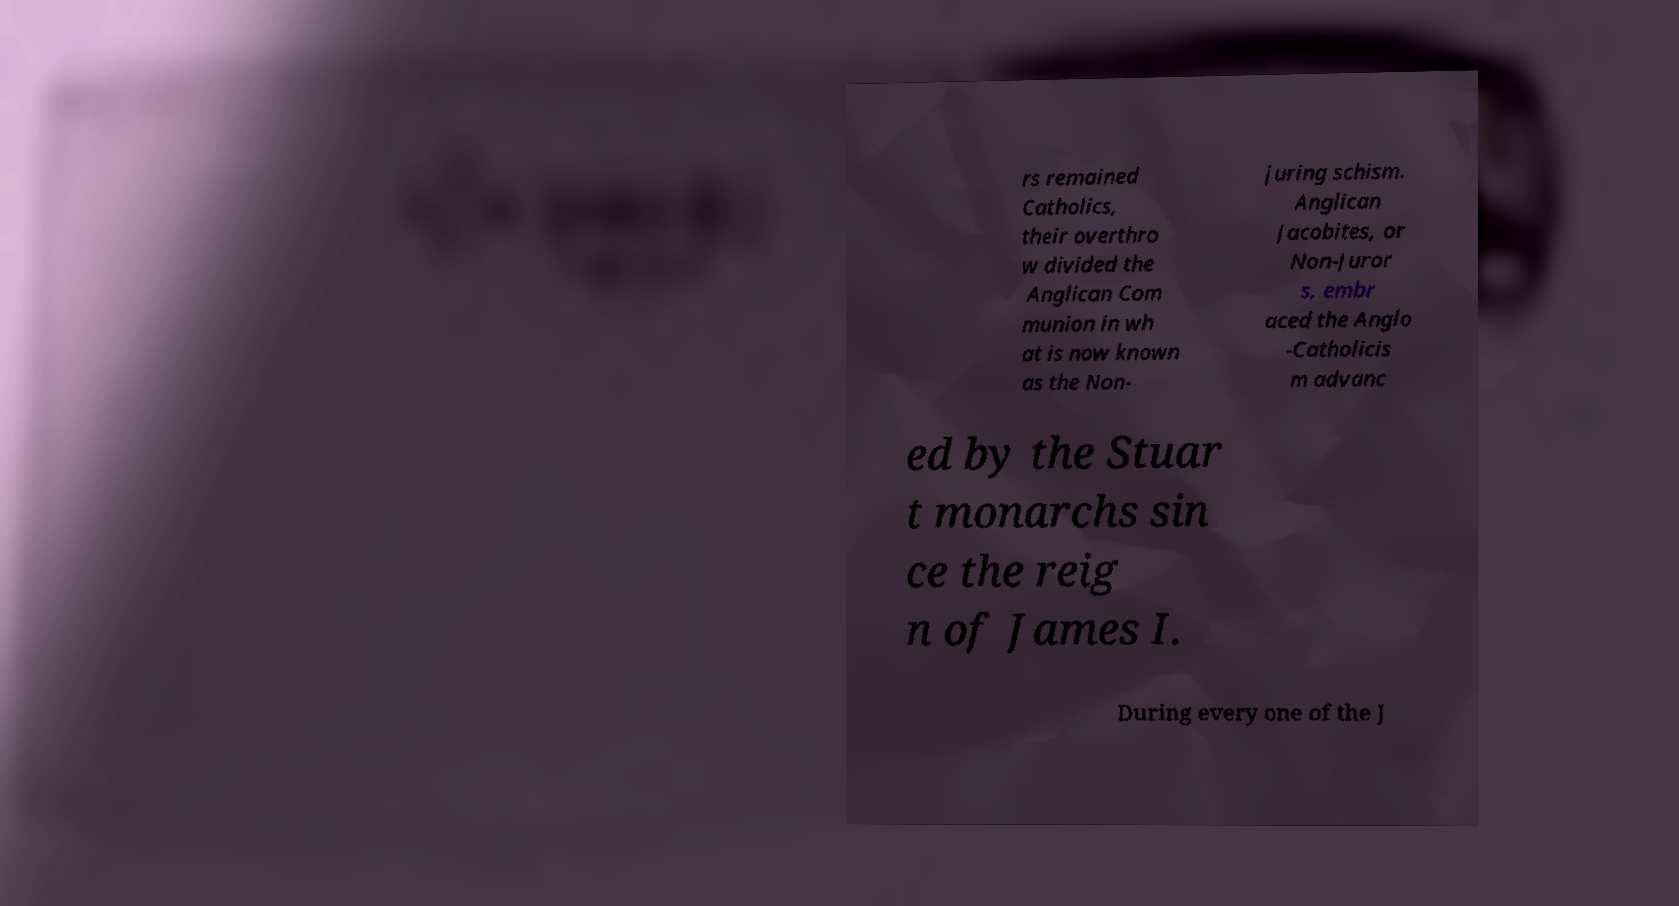Please read and relay the text visible in this image. What does it say? rs remained Catholics, their overthro w divided the Anglican Com munion in wh at is now known as the Non- juring schism. Anglican Jacobites, or Non-Juror s, embr aced the Anglo -Catholicis m advanc ed by the Stuar t monarchs sin ce the reig n of James I. During every one of the J 